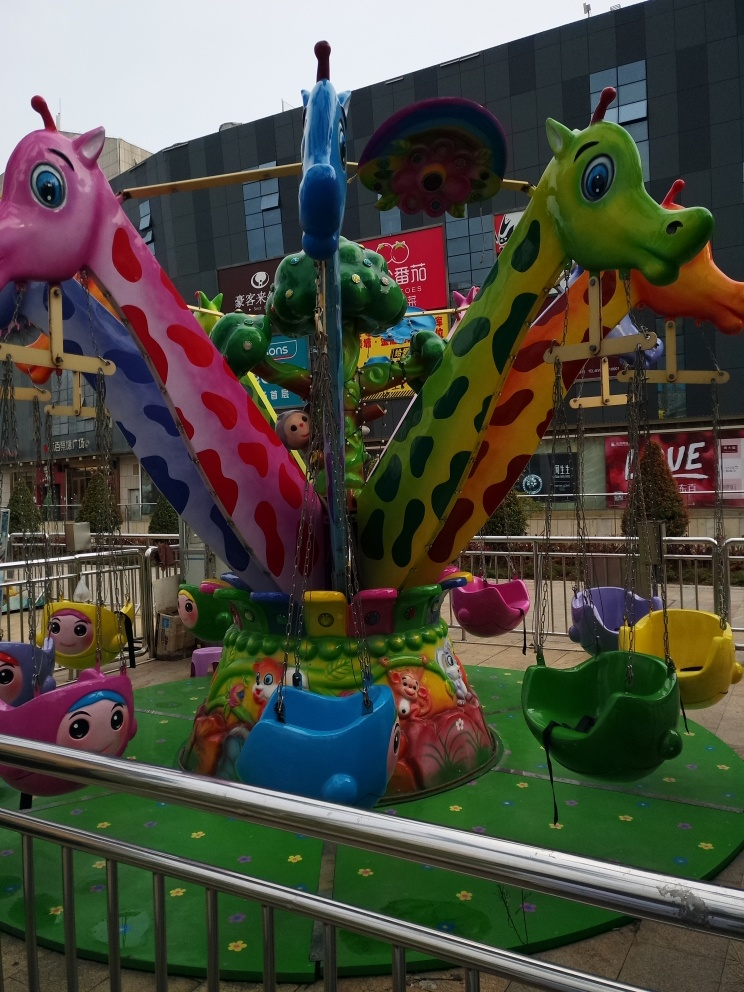What can this image tell us about the location? The image provides clues that the location is likely urban and family-friendly. The presence of the shopping mall in the background, along with the large advertisements on the building, suggests a commercial area where families might gather for shopping and entertainment. The pavements and the safety railings around the carousel also indicate a well-organized public space. 